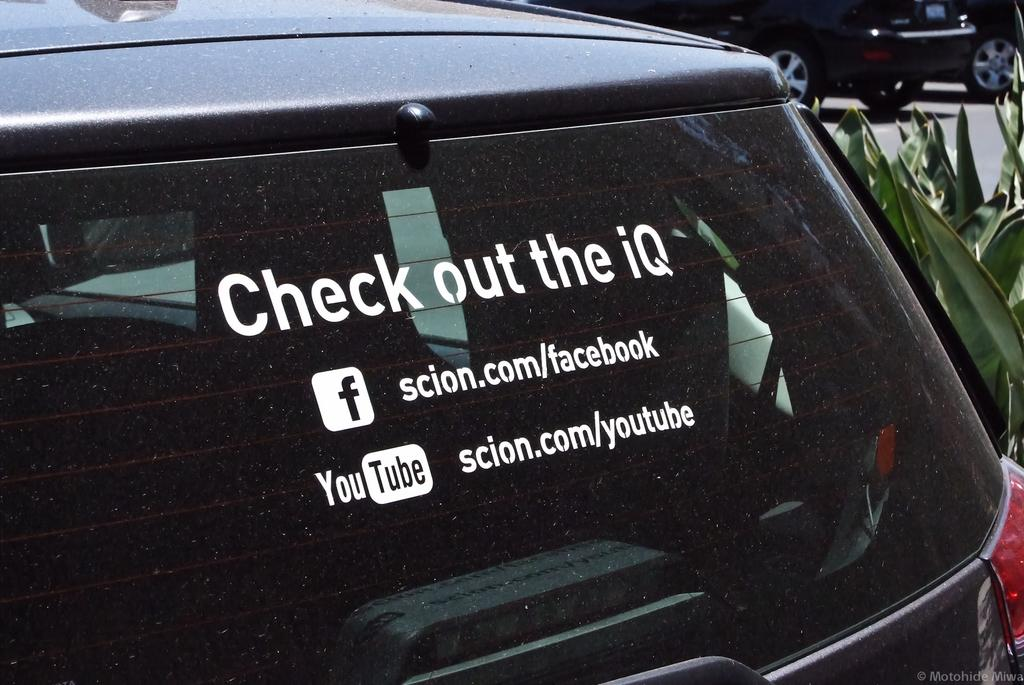What can be seen on the vehicle glass in the image? There is text on the vehicle glass in the image. What is present at the bottom of the image? There is a watermark at the bottom of the image. What type of vegetation is on the right side of the image? There are plants on the right side of the image. What is happening in the image involving transportation? There are vehicles on the road in the image. What type of care is being advertised in the image? There is no advertisement present in the image, so it is not possible to determine what type of care is being advertised. 